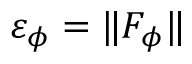<formula> <loc_0><loc_0><loc_500><loc_500>\varepsilon _ { \phi } = \| F _ { \phi } \|</formula> 